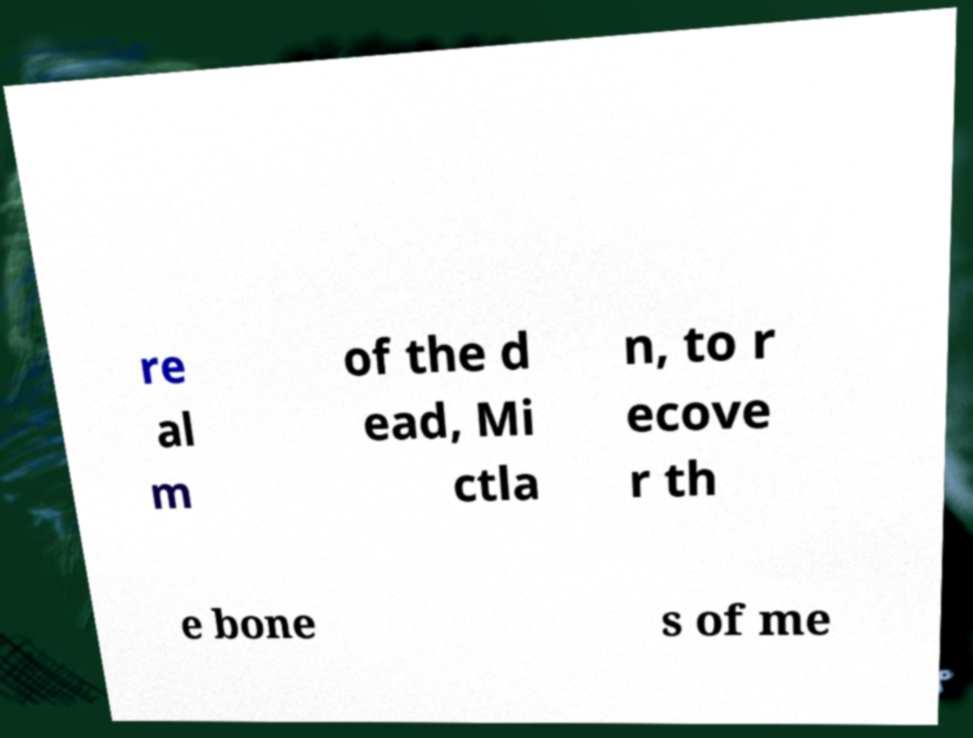Can you accurately transcribe the text from the provided image for me? re al m of the d ead, Mi ctla n, to r ecove r th e bone s of me 